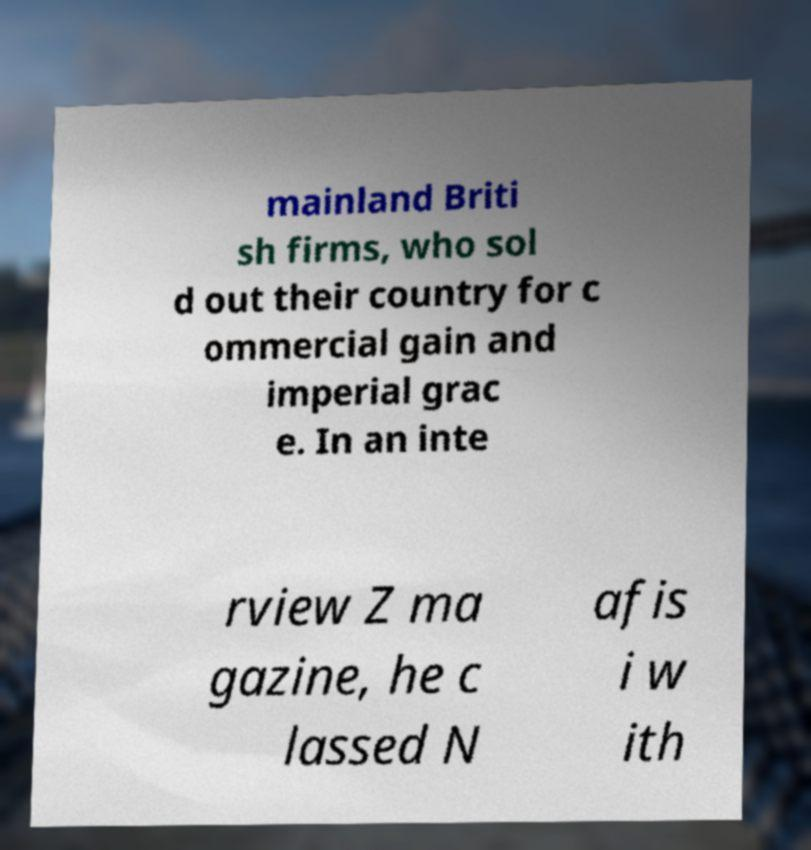There's text embedded in this image that I need extracted. Can you transcribe it verbatim? mainland Briti sh firms, who sol d out their country for c ommercial gain and imperial grac e. In an inte rview Z ma gazine, he c lassed N afis i w ith 